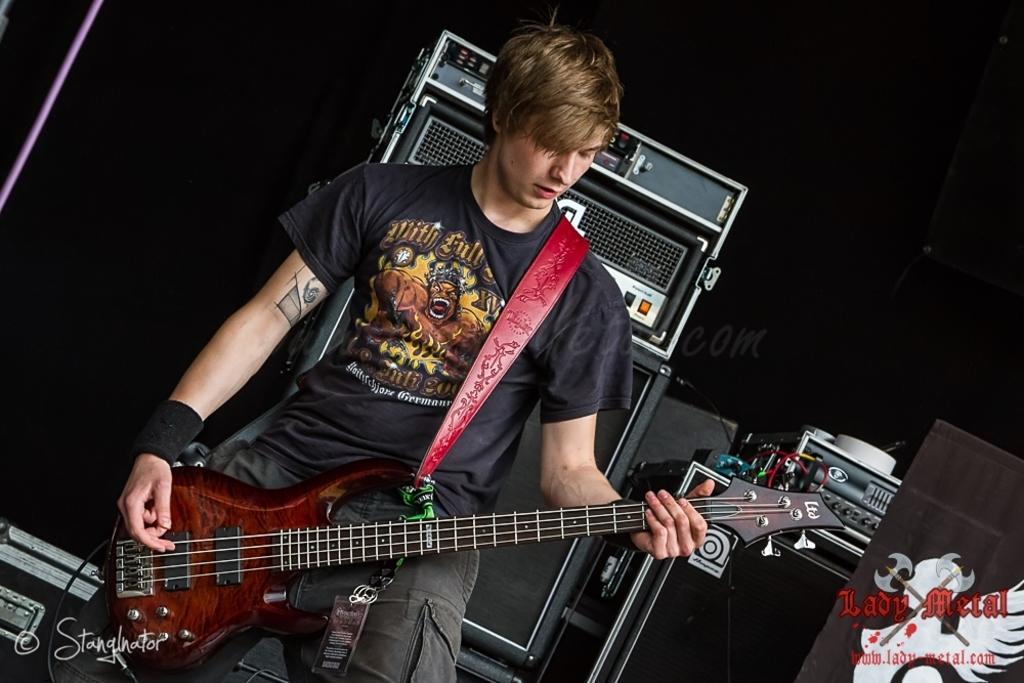How would you summarize this image in a sentence or two? This is the picture of a guy in black shirt and black pant holding a guitar and playing it and behind him there are some speakers and some other musical instruments. 